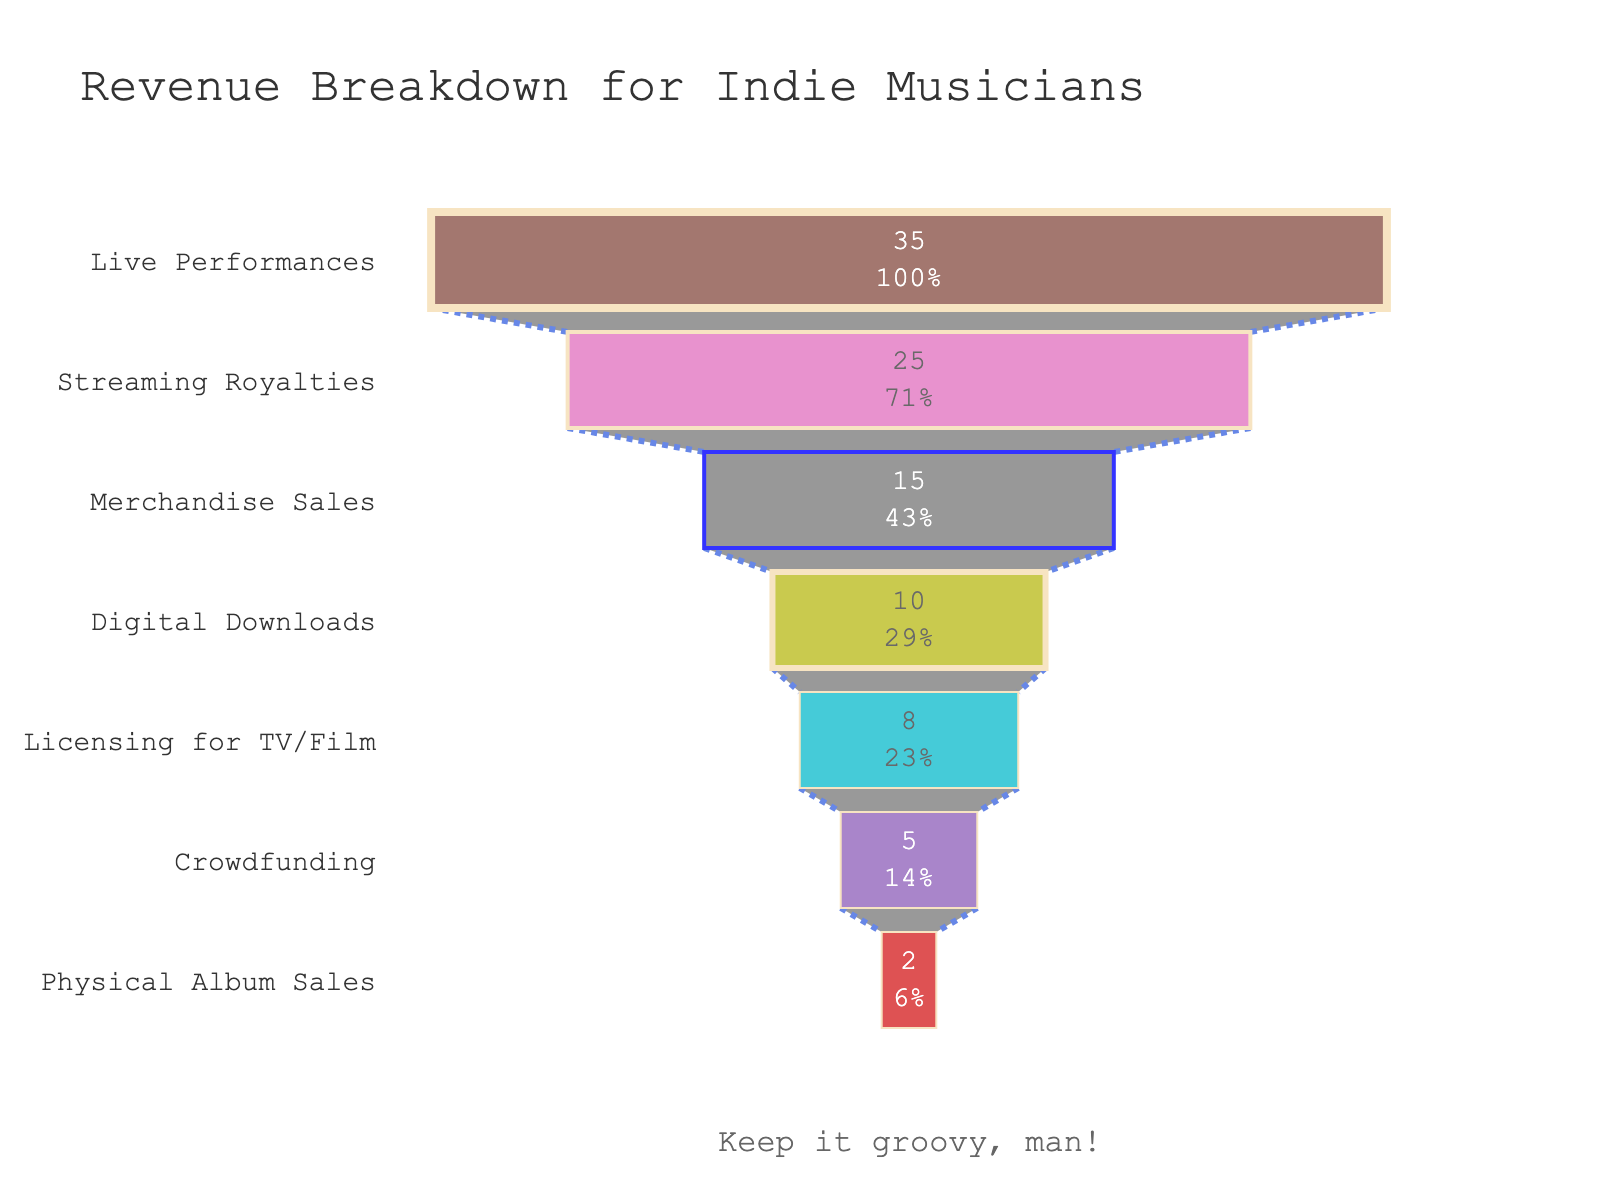Which revenue source contributes the most to the revenue for indie musicians? To find which revenue source contributes the most, look at the largest segment at the top of the funnel chart. The segment labeled "Live Performances" is the largest, representing 35%.
Answer: Live Performances What percentage of revenue comes from Merchandise Sales? Identify the segment labeled "Merchandise Sales" in the funnel chart, which indicates the percentage. It is noted as 15%.
Answer: 15% What are the second and third highest revenue sources and their percentages? First, identify the second largest segment, which is "Streaming Royalties" with 25%. The third largest is "Merchandise Sales" with 15%.
Answer: Streaming Royalties (25%) and Merchandise Sales (15%) How much more revenue is generated from Streaming Royalties compared to Digital Downloads? Find the percentage for Streaming Royalties (25%) and Digital Downloads (10%). Subtract the percentage of Digital Downloads from Streaming Royalties: 25% - 10% = 15%.
Answer: 15% What is the total percentage of revenue from Live Performances, Streaming Royalties, and Merchandise Sales combined? Add the percentages of the three highest revenue sources: Live Performances (35%), Streaming Royalties (25%), and Merchandise Sales (15%). 35% + 25% + 15% = 75%.
Answer: 75% Which revenue source contributes the least to indie musicians' income? Find the smallest segment at the bottom of the funnel chart. This is "Physical Album Sales", which is 2%.
Answer: Physical Album Sales How does the percentage of Crowdfunding compare to Licensing for TV/Film? Identify the percentages of Crowdfunding (5%) and Licensing for TV/Film (8%). Since 5% < 8%, Crowdfunding contributes less.
Answer: Less What is the difference in percentage between Licensing for TV/Film and Digital Downloads? Find the percentages for Licensing for TV/Film (8%) and Digital Downloads (10%). Subtract Licensing for TV/Film from Digital Downloads: 10% - 8% = 2%.
Answer: 2% What is the combined percentage of revenue from Licensing for TV/Film and Crowdfunding? Add the percentages of Licensing for TV/Film (8%) and Crowdfunding (5%): 8% + 5% = 13%.
Answer: 13% How much more revenue is generated from Live Performances than from Physical Album Sales? Identify the percentage for Live Performances (35%) and Physical Album Sales (2%). Subtract Physical Album Sales from Live Performances: 35% - 2% = 33%.
Answer: 33% 